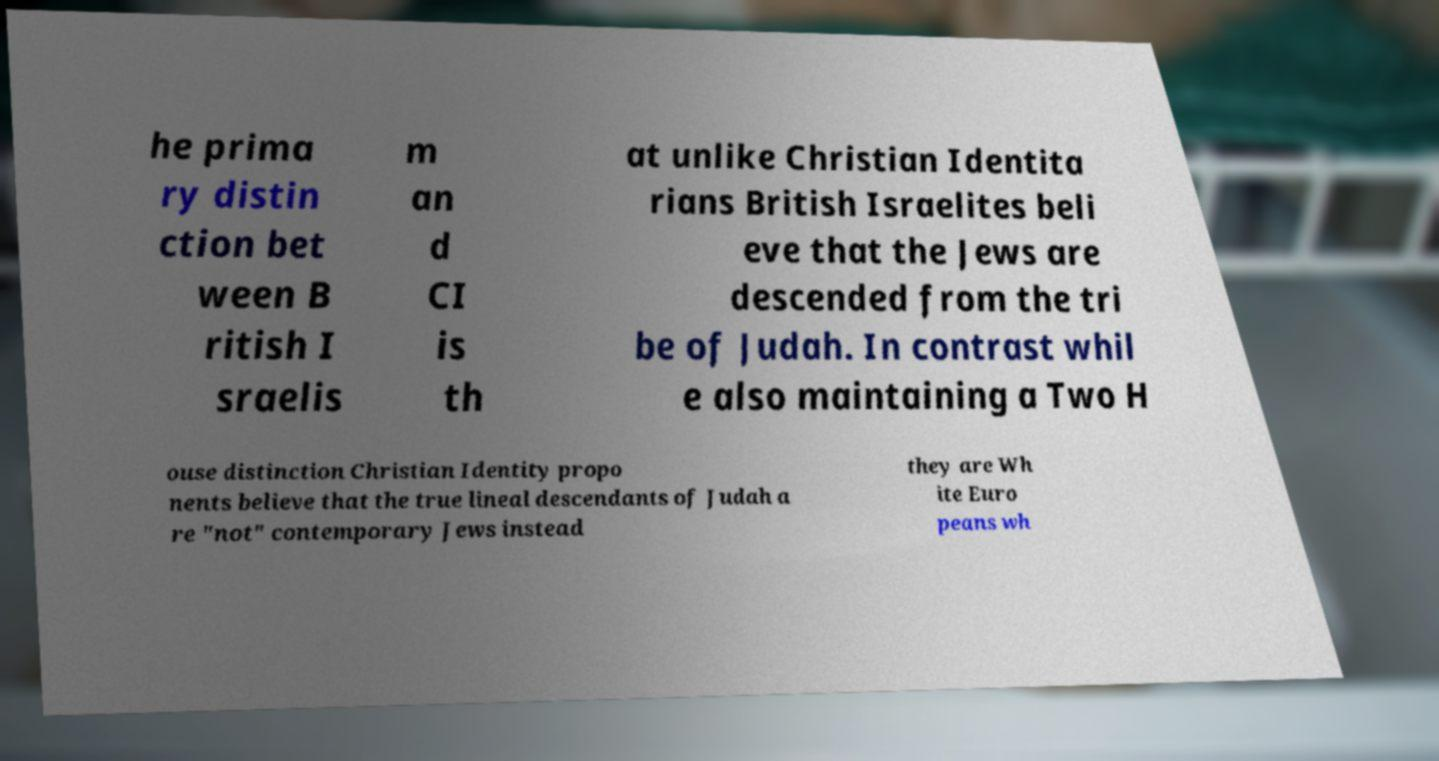There's text embedded in this image that I need extracted. Can you transcribe it verbatim? he prima ry distin ction bet ween B ritish I sraelis m an d CI is th at unlike Christian Identita rians British Israelites beli eve that the Jews are descended from the tri be of Judah. In contrast whil e also maintaining a Two H ouse distinction Christian Identity propo nents believe that the true lineal descendants of Judah a re "not" contemporary Jews instead they are Wh ite Euro peans wh 